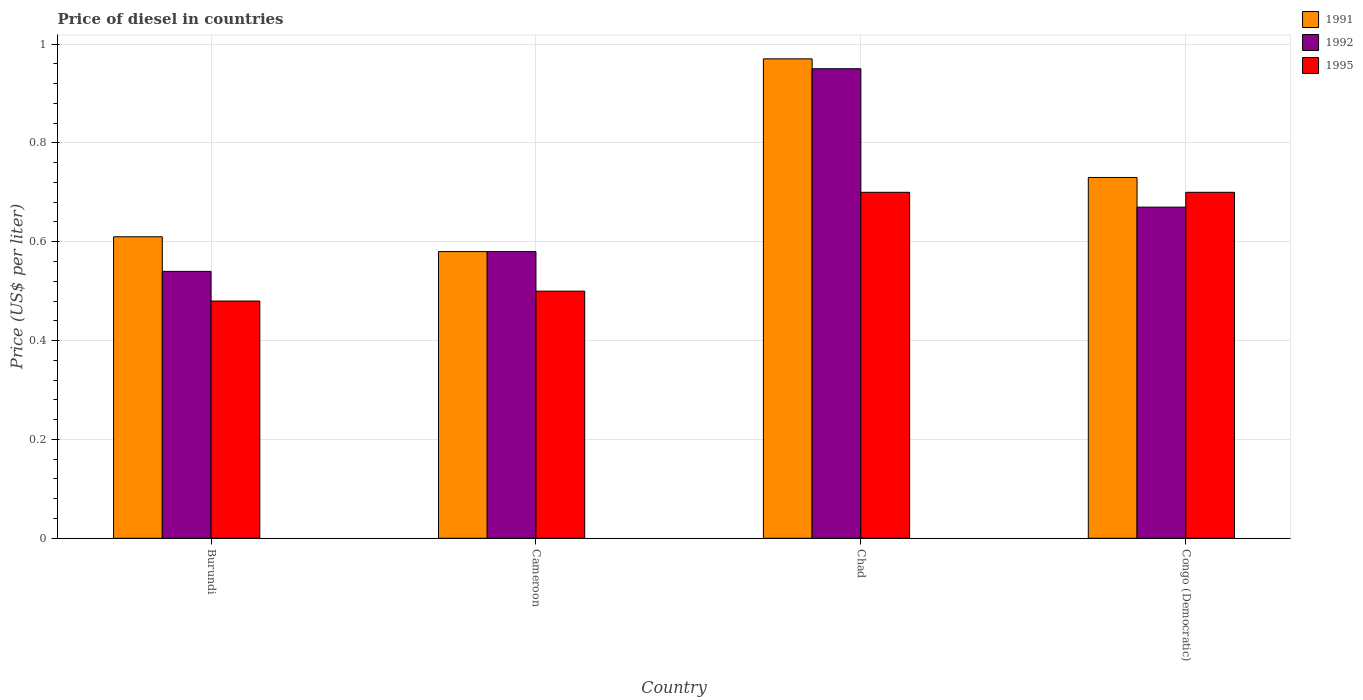How many groups of bars are there?
Your response must be concise. 4. How many bars are there on the 4th tick from the left?
Ensure brevity in your answer.  3. What is the label of the 4th group of bars from the left?
Offer a very short reply. Congo (Democratic). In how many cases, is the number of bars for a given country not equal to the number of legend labels?
Provide a short and direct response. 0. Across all countries, what is the minimum price of diesel in 1991?
Your answer should be compact. 0.58. In which country was the price of diesel in 1991 maximum?
Your response must be concise. Chad. In which country was the price of diesel in 1992 minimum?
Your answer should be very brief. Burundi. What is the total price of diesel in 1992 in the graph?
Your response must be concise. 2.74. What is the difference between the price of diesel in 1995 in Burundi and that in Cameroon?
Give a very brief answer. -0.02. What is the difference between the price of diesel in 1995 in Congo (Democratic) and the price of diesel in 1991 in Chad?
Make the answer very short. -0.27. What is the average price of diesel in 1991 per country?
Offer a terse response. 0.72. What is the difference between the price of diesel of/in 1995 and price of diesel of/in 1992 in Cameroon?
Offer a very short reply. -0.08. What is the ratio of the price of diesel in 1995 in Chad to that in Congo (Democratic)?
Offer a very short reply. 1. What is the difference between the highest and the second highest price of diesel in 1995?
Offer a terse response. 0.2. What is the difference between the highest and the lowest price of diesel in 1991?
Your answer should be compact. 0.39. What does the 1st bar from the left in Burundi represents?
Your answer should be very brief. 1991. What does the 1st bar from the right in Congo (Democratic) represents?
Offer a terse response. 1995. How many bars are there?
Provide a short and direct response. 12. Are all the bars in the graph horizontal?
Offer a terse response. No. How many countries are there in the graph?
Give a very brief answer. 4. What is the difference between two consecutive major ticks on the Y-axis?
Your response must be concise. 0.2. Does the graph contain any zero values?
Your answer should be very brief. No. Does the graph contain grids?
Ensure brevity in your answer.  Yes. How are the legend labels stacked?
Keep it short and to the point. Vertical. What is the title of the graph?
Give a very brief answer. Price of diesel in countries. Does "1964" appear as one of the legend labels in the graph?
Make the answer very short. No. What is the label or title of the Y-axis?
Offer a very short reply. Price (US$ per liter). What is the Price (US$ per liter) in 1991 in Burundi?
Provide a short and direct response. 0.61. What is the Price (US$ per liter) in 1992 in Burundi?
Your response must be concise. 0.54. What is the Price (US$ per liter) of 1995 in Burundi?
Give a very brief answer. 0.48. What is the Price (US$ per liter) in 1991 in Cameroon?
Offer a very short reply. 0.58. What is the Price (US$ per liter) in 1992 in Cameroon?
Your response must be concise. 0.58. What is the Price (US$ per liter) in 1995 in Cameroon?
Keep it short and to the point. 0.5. What is the Price (US$ per liter) of 1992 in Chad?
Give a very brief answer. 0.95. What is the Price (US$ per liter) in 1995 in Chad?
Provide a succinct answer. 0.7. What is the Price (US$ per liter) of 1991 in Congo (Democratic)?
Offer a terse response. 0.73. What is the Price (US$ per liter) in 1992 in Congo (Democratic)?
Make the answer very short. 0.67. Across all countries, what is the minimum Price (US$ per liter) in 1991?
Offer a terse response. 0.58. Across all countries, what is the minimum Price (US$ per liter) of 1992?
Give a very brief answer. 0.54. Across all countries, what is the minimum Price (US$ per liter) in 1995?
Make the answer very short. 0.48. What is the total Price (US$ per liter) of 1991 in the graph?
Ensure brevity in your answer.  2.89. What is the total Price (US$ per liter) of 1992 in the graph?
Make the answer very short. 2.74. What is the total Price (US$ per liter) of 1995 in the graph?
Make the answer very short. 2.38. What is the difference between the Price (US$ per liter) in 1991 in Burundi and that in Cameroon?
Make the answer very short. 0.03. What is the difference between the Price (US$ per liter) of 1992 in Burundi and that in Cameroon?
Ensure brevity in your answer.  -0.04. What is the difference between the Price (US$ per liter) of 1995 in Burundi and that in Cameroon?
Provide a short and direct response. -0.02. What is the difference between the Price (US$ per liter) in 1991 in Burundi and that in Chad?
Your response must be concise. -0.36. What is the difference between the Price (US$ per liter) of 1992 in Burundi and that in Chad?
Ensure brevity in your answer.  -0.41. What is the difference between the Price (US$ per liter) of 1995 in Burundi and that in Chad?
Ensure brevity in your answer.  -0.22. What is the difference between the Price (US$ per liter) of 1991 in Burundi and that in Congo (Democratic)?
Your answer should be very brief. -0.12. What is the difference between the Price (US$ per liter) in 1992 in Burundi and that in Congo (Democratic)?
Ensure brevity in your answer.  -0.13. What is the difference between the Price (US$ per liter) of 1995 in Burundi and that in Congo (Democratic)?
Your response must be concise. -0.22. What is the difference between the Price (US$ per liter) in 1991 in Cameroon and that in Chad?
Ensure brevity in your answer.  -0.39. What is the difference between the Price (US$ per liter) of 1992 in Cameroon and that in Chad?
Your answer should be compact. -0.37. What is the difference between the Price (US$ per liter) of 1995 in Cameroon and that in Chad?
Give a very brief answer. -0.2. What is the difference between the Price (US$ per liter) of 1991 in Cameroon and that in Congo (Democratic)?
Provide a short and direct response. -0.15. What is the difference between the Price (US$ per liter) in 1992 in Cameroon and that in Congo (Democratic)?
Your response must be concise. -0.09. What is the difference between the Price (US$ per liter) of 1991 in Chad and that in Congo (Democratic)?
Your response must be concise. 0.24. What is the difference between the Price (US$ per liter) in 1992 in Chad and that in Congo (Democratic)?
Provide a short and direct response. 0.28. What is the difference between the Price (US$ per liter) of 1995 in Chad and that in Congo (Democratic)?
Give a very brief answer. 0. What is the difference between the Price (US$ per liter) in 1991 in Burundi and the Price (US$ per liter) in 1995 in Cameroon?
Your response must be concise. 0.11. What is the difference between the Price (US$ per liter) of 1991 in Burundi and the Price (US$ per liter) of 1992 in Chad?
Your answer should be compact. -0.34. What is the difference between the Price (US$ per liter) in 1991 in Burundi and the Price (US$ per liter) in 1995 in Chad?
Offer a very short reply. -0.09. What is the difference between the Price (US$ per liter) in 1992 in Burundi and the Price (US$ per liter) in 1995 in Chad?
Keep it short and to the point. -0.16. What is the difference between the Price (US$ per liter) in 1991 in Burundi and the Price (US$ per liter) in 1992 in Congo (Democratic)?
Your answer should be compact. -0.06. What is the difference between the Price (US$ per liter) in 1991 in Burundi and the Price (US$ per liter) in 1995 in Congo (Democratic)?
Ensure brevity in your answer.  -0.09. What is the difference between the Price (US$ per liter) of 1992 in Burundi and the Price (US$ per liter) of 1995 in Congo (Democratic)?
Offer a very short reply. -0.16. What is the difference between the Price (US$ per liter) in 1991 in Cameroon and the Price (US$ per liter) in 1992 in Chad?
Your answer should be compact. -0.37. What is the difference between the Price (US$ per liter) of 1991 in Cameroon and the Price (US$ per liter) of 1995 in Chad?
Offer a terse response. -0.12. What is the difference between the Price (US$ per liter) of 1992 in Cameroon and the Price (US$ per liter) of 1995 in Chad?
Give a very brief answer. -0.12. What is the difference between the Price (US$ per liter) of 1991 in Cameroon and the Price (US$ per liter) of 1992 in Congo (Democratic)?
Give a very brief answer. -0.09. What is the difference between the Price (US$ per liter) of 1991 in Cameroon and the Price (US$ per liter) of 1995 in Congo (Democratic)?
Keep it short and to the point. -0.12. What is the difference between the Price (US$ per liter) in 1992 in Cameroon and the Price (US$ per liter) in 1995 in Congo (Democratic)?
Your answer should be very brief. -0.12. What is the difference between the Price (US$ per liter) in 1991 in Chad and the Price (US$ per liter) in 1995 in Congo (Democratic)?
Provide a short and direct response. 0.27. What is the difference between the Price (US$ per liter) of 1992 in Chad and the Price (US$ per liter) of 1995 in Congo (Democratic)?
Ensure brevity in your answer.  0.25. What is the average Price (US$ per liter) in 1991 per country?
Make the answer very short. 0.72. What is the average Price (US$ per liter) of 1992 per country?
Your response must be concise. 0.69. What is the average Price (US$ per liter) in 1995 per country?
Your response must be concise. 0.59. What is the difference between the Price (US$ per liter) in 1991 and Price (US$ per liter) in 1992 in Burundi?
Your answer should be very brief. 0.07. What is the difference between the Price (US$ per liter) of 1991 and Price (US$ per liter) of 1995 in Burundi?
Offer a very short reply. 0.13. What is the difference between the Price (US$ per liter) in 1991 and Price (US$ per liter) in 1995 in Chad?
Make the answer very short. 0.27. What is the difference between the Price (US$ per liter) of 1992 and Price (US$ per liter) of 1995 in Chad?
Offer a terse response. 0.25. What is the difference between the Price (US$ per liter) in 1991 and Price (US$ per liter) in 1992 in Congo (Democratic)?
Give a very brief answer. 0.06. What is the difference between the Price (US$ per liter) of 1992 and Price (US$ per liter) of 1995 in Congo (Democratic)?
Your answer should be very brief. -0.03. What is the ratio of the Price (US$ per liter) of 1991 in Burundi to that in Cameroon?
Your answer should be very brief. 1.05. What is the ratio of the Price (US$ per liter) in 1992 in Burundi to that in Cameroon?
Offer a very short reply. 0.93. What is the ratio of the Price (US$ per liter) of 1995 in Burundi to that in Cameroon?
Your answer should be very brief. 0.96. What is the ratio of the Price (US$ per liter) in 1991 in Burundi to that in Chad?
Ensure brevity in your answer.  0.63. What is the ratio of the Price (US$ per liter) in 1992 in Burundi to that in Chad?
Give a very brief answer. 0.57. What is the ratio of the Price (US$ per liter) of 1995 in Burundi to that in Chad?
Ensure brevity in your answer.  0.69. What is the ratio of the Price (US$ per liter) of 1991 in Burundi to that in Congo (Democratic)?
Make the answer very short. 0.84. What is the ratio of the Price (US$ per liter) of 1992 in Burundi to that in Congo (Democratic)?
Offer a very short reply. 0.81. What is the ratio of the Price (US$ per liter) in 1995 in Burundi to that in Congo (Democratic)?
Offer a terse response. 0.69. What is the ratio of the Price (US$ per liter) of 1991 in Cameroon to that in Chad?
Keep it short and to the point. 0.6. What is the ratio of the Price (US$ per liter) in 1992 in Cameroon to that in Chad?
Offer a terse response. 0.61. What is the ratio of the Price (US$ per liter) in 1991 in Cameroon to that in Congo (Democratic)?
Your answer should be compact. 0.79. What is the ratio of the Price (US$ per liter) in 1992 in Cameroon to that in Congo (Democratic)?
Make the answer very short. 0.87. What is the ratio of the Price (US$ per liter) of 1995 in Cameroon to that in Congo (Democratic)?
Your response must be concise. 0.71. What is the ratio of the Price (US$ per liter) in 1991 in Chad to that in Congo (Democratic)?
Ensure brevity in your answer.  1.33. What is the ratio of the Price (US$ per liter) in 1992 in Chad to that in Congo (Democratic)?
Ensure brevity in your answer.  1.42. What is the ratio of the Price (US$ per liter) of 1995 in Chad to that in Congo (Democratic)?
Your answer should be compact. 1. What is the difference between the highest and the second highest Price (US$ per liter) in 1991?
Offer a very short reply. 0.24. What is the difference between the highest and the second highest Price (US$ per liter) in 1992?
Your response must be concise. 0.28. What is the difference between the highest and the lowest Price (US$ per liter) in 1991?
Provide a succinct answer. 0.39. What is the difference between the highest and the lowest Price (US$ per liter) in 1992?
Make the answer very short. 0.41. What is the difference between the highest and the lowest Price (US$ per liter) in 1995?
Give a very brief answer. 0.22. 